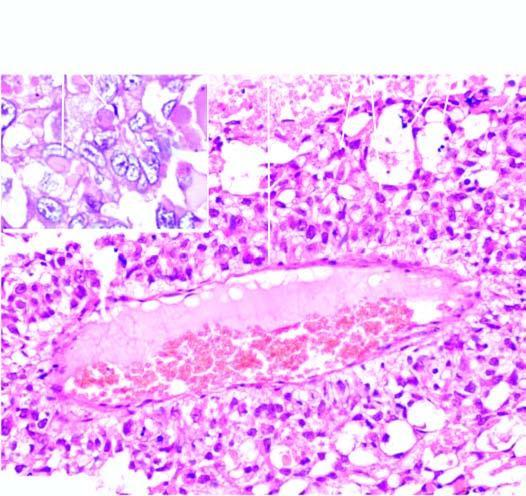what shows intra - and extracellular hyaline globules?
Answer the question using a single word or phrase. Specimen of the uterus 